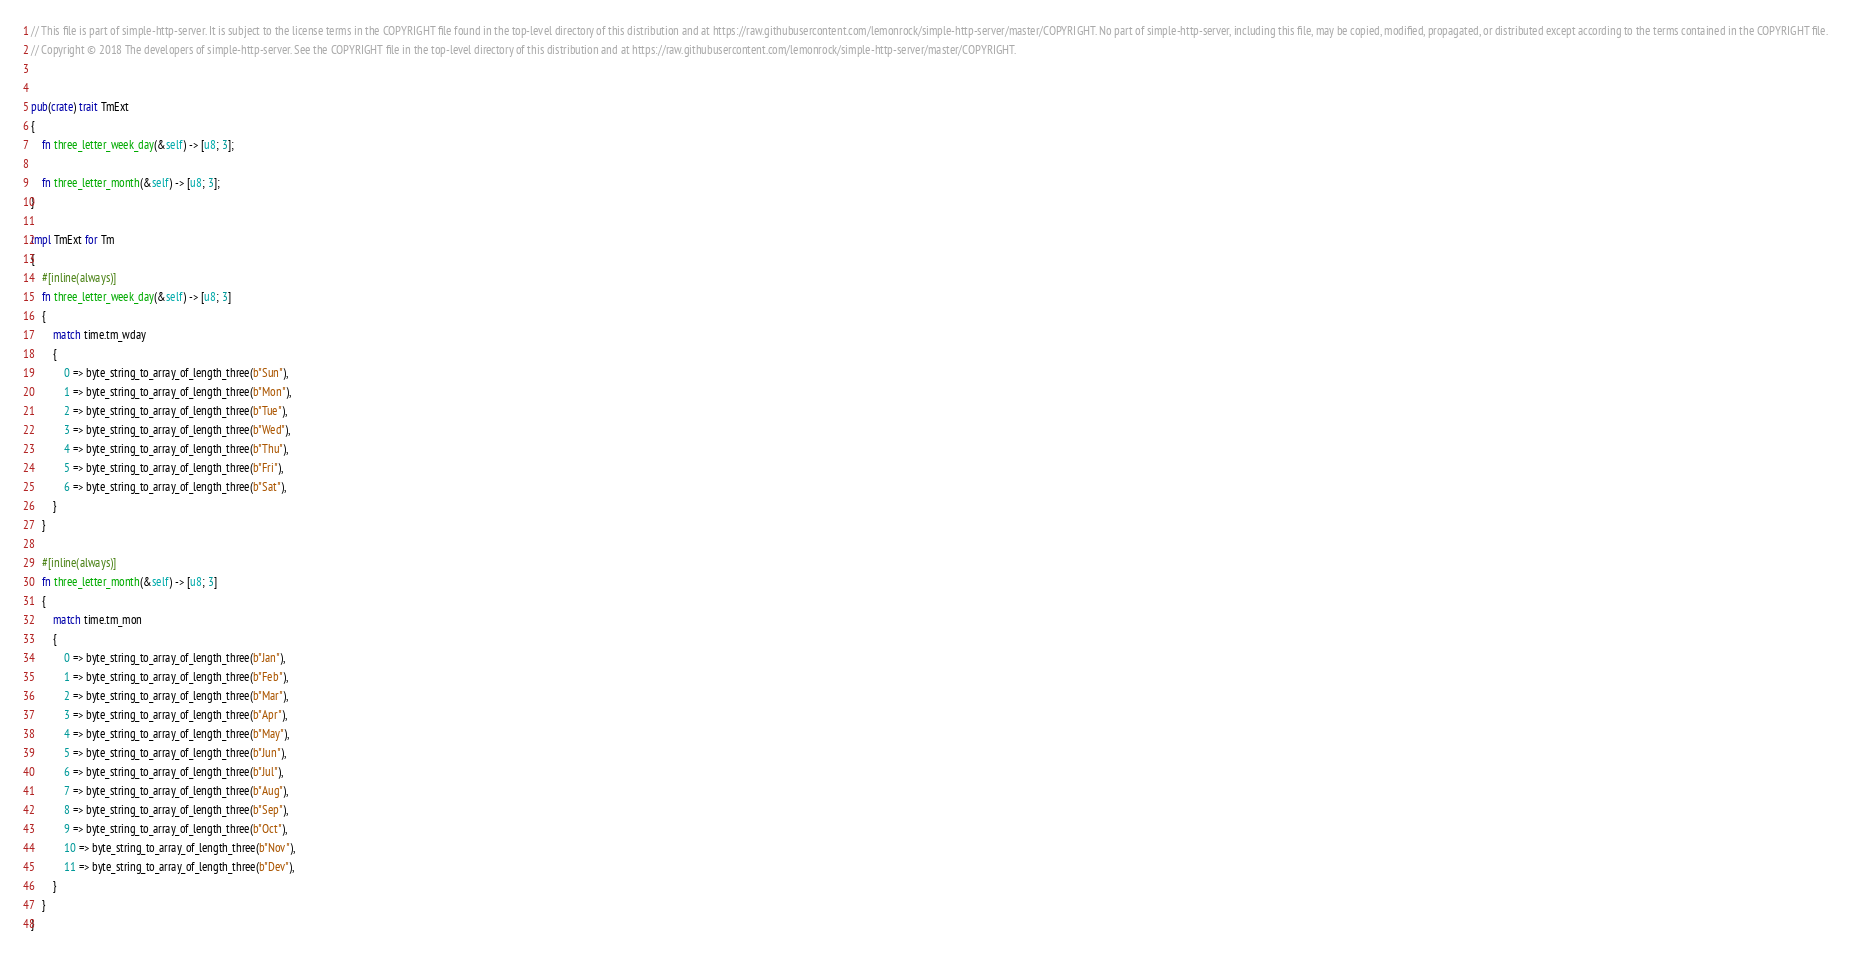Convert code to text. <code><loc_0><loc_0><loc_500><loc_500><_Rust_>// This file is part of simple-http-server. It is subject to the license terms in the COPYRIGHT file found in the top-level directory of this distribution and at https://raw.githubusercontent.com/lemonrock/simple-http-server/master/COPYRIGHT. No part of simple-http-server, including this file, may be copied, modified, propagated, or distributed except according to the terms contained in the COPYRIGHT file.
// Copyright © 2018 The developers of simple-http-server. See the COPYRIGHT file in the top-level directory of this distribution and at https://raw.githubusercontent.com/lemonrock/simple-http-server/master/COPYRIGHT.


pub(crate) trait TmExt
{
	fn three_letter_week_day(&self) -> [u8; 3];

	fn three_letter_month(&self) -> [u8; 3];
}

impl TmExt for Tm
{
	#[inline(always)]
	fn three_letter_week_day(&self) -> [u8; 3]
	{
		match time.tm_wday
		{
			0 => byte_string_to_array_of_length_three(b"Sun"),
			1 => byte_string_to_array_of_length_three(b"Mon"),
			2 => byte_string_to_array_of_length_three(b"Tue"),
			3 => byte_string_to_array_of_length_three(b"Wed"),
			4 => byte_string_to_array_of_length_three(b"Thu"),
			5 => byte_string_to_array_of_length_three(b"Fri"),
			6 => byte_string_to_array_of_length_three(b"Sat"),
		}
	}

	#[inline(always)]
	fn three_letter_month(&self) -> [u8; 3]
	{
		match time.tm_mon
		{
			0 => byte_string_to_array_of_length_three(b"Jan"),
			1 => byte_string_to_array_of_length_three(b"Feb"),
			2 => byte_string_to_array_of_length_three(b"Mar"),
			3 => byte_string_to_array_of_length_three(b"Apr"),
			4 => byte_string_to_array_of_length_three(b"May"),
			5 => byte_string_to_array_of_length_three(b"Jun"),
			6 => byte_string_to_array_of_length_three(b"Jul"),
			7 => byte_string_to_array_of_length_three(b"Aug"),
			8 => byte_string_to_array_of_length_three(b"Sep"),
			9 => byte_string_to_array_of_length_three(b"Oct"),
			10 => byte_string_to_array_of_length_three(b"Nov"),
			11 => byte_string_to_array_of_length_three(b"Dev"),
		}
	}
}
</code> 